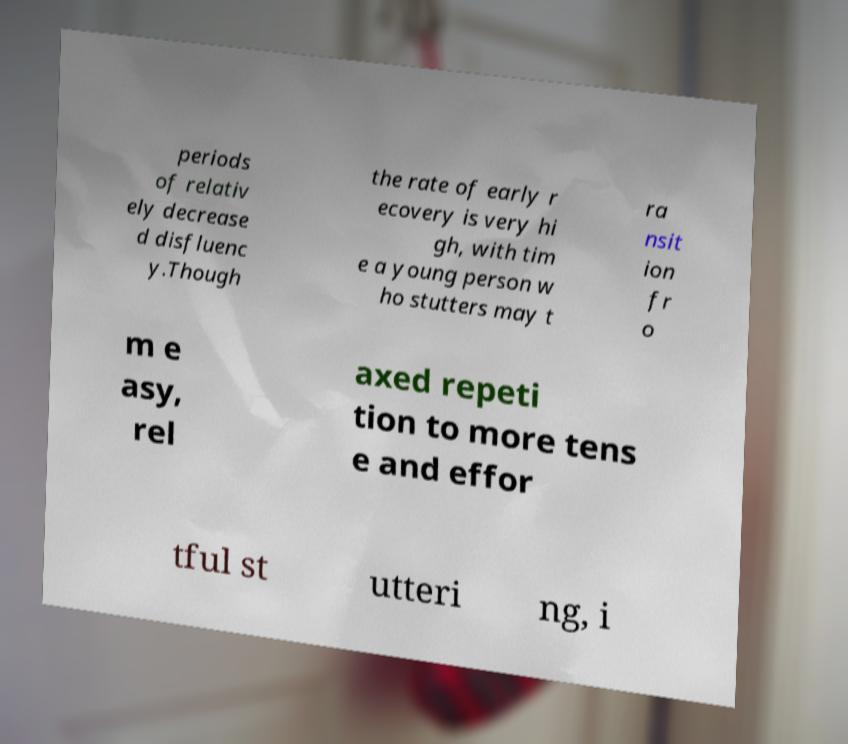Could you extract and type out the text from this image? periods of relativ ely decrease d disfluenc y.Though the rate of early r ecovery is very hi gh, with tim e a young person w ho stutters may t ra nsit ion fr o m e asy, rel axed repeti tion to more tens e and effor tful st utteri ng, i 